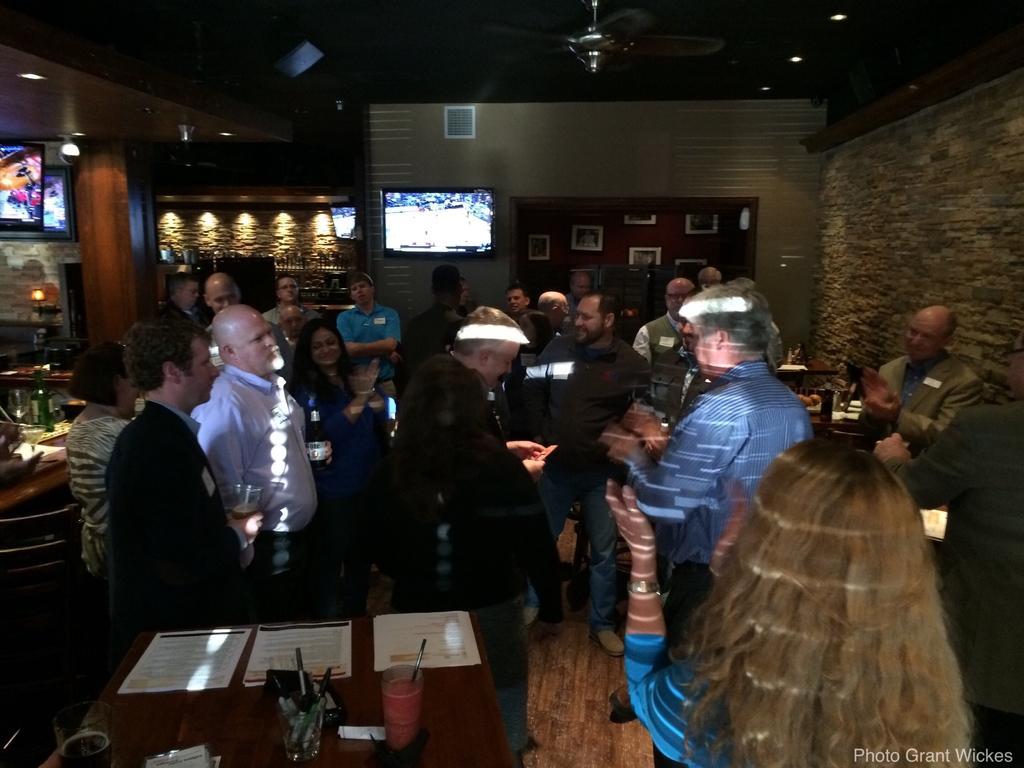Can you describe this image briefly? In the image there are many people standing and holding wine glasses, some people are clapping, this seems to be inside a restaurant, on the left side there is a table with glass and menu cards on it, in the back there is tv on the wall with photographs and lights on either side of it. 